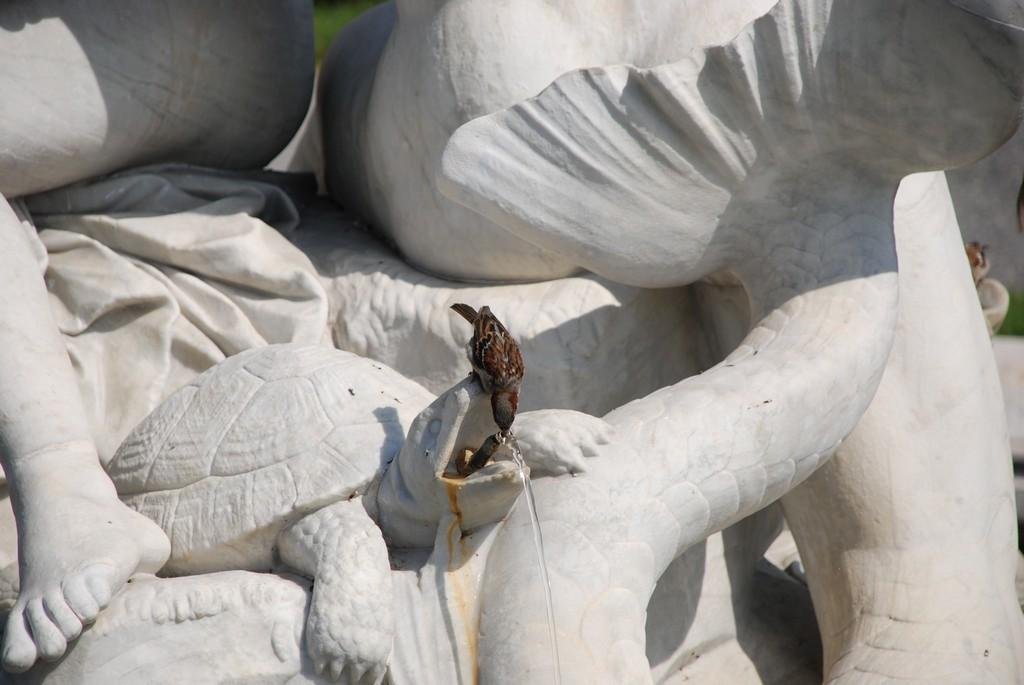What type of animal is the main subject of the sculpture in the image? The main subject of the sculpture is a tortoise. What other features are included in the sculpture? The sculpture includes a fish tail and a person's leg. What is the bird doing on the tortoise sculpture? The bird is depicted as drinking water. Where can you find the best oranges in the image? There are no oranges present in the image, so it is not possible to determine where the best ones might be found. 